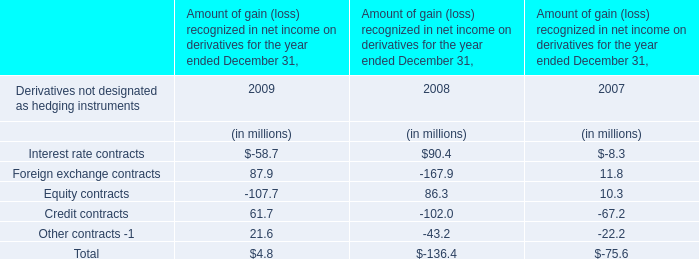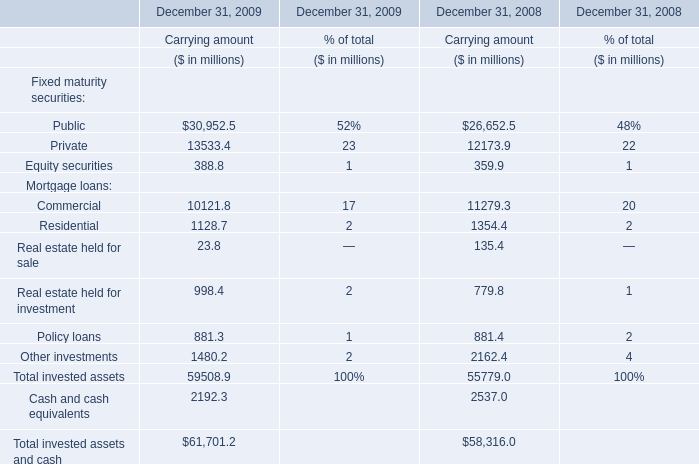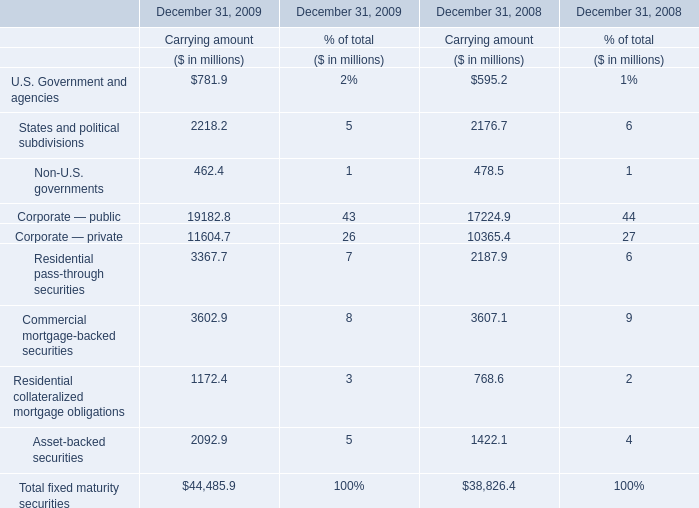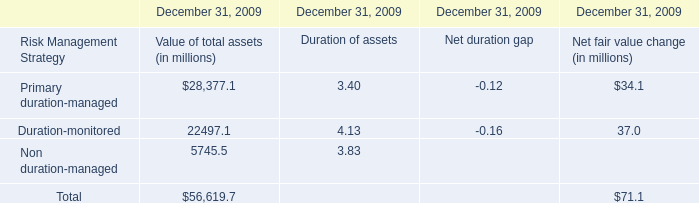What is the difference between the greatest mortgage loans in 2009 and 2008？ (in million) 
Computations: (10121.8 - 11279.3)
Answer: -1157.5. 